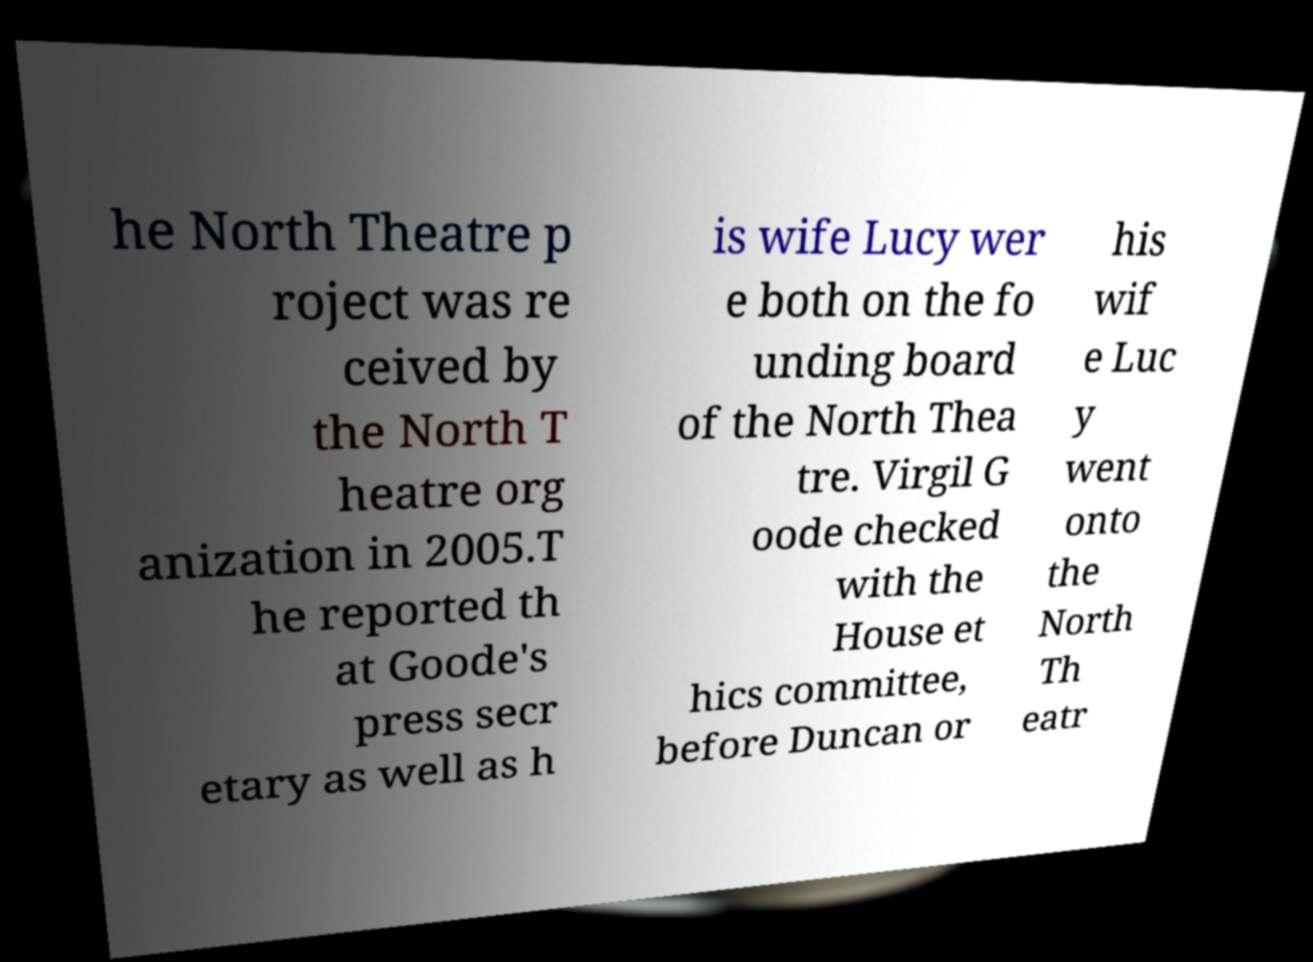Could you extract and type out the text from this image? he North Theatre p roject was re ceived by the North T heatre org anization in 2005.T he reported th at Goode's press secr etary as well as h is wife Lucy wer e both on the fo unding board of the North Thea tre. Virgil G oode checked with the House et hics committee, before Duncan or his wif e Luc y went onto the North Th eatr 